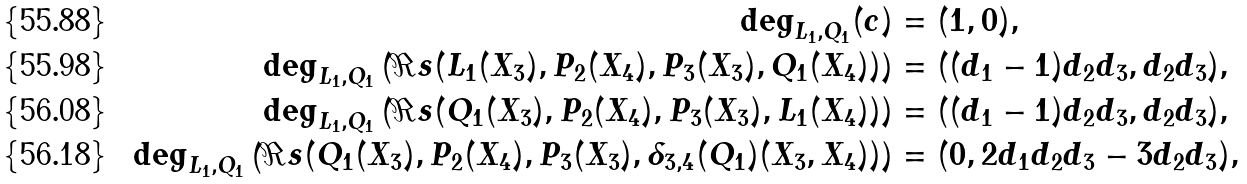<formula> <loc_0><loc_0><loc_500><loc_500>\deg _ { L _ { 1 } , Q _ { 1 } } ( c ) & = ( 1 , 0 ) , \\ \deg _ { L _ { 1 } , Q _ { 1 } } \left ( \Re s ( L _ { 1 } ( X _ { 3 } ) , P _ { 2 } ( X _ { 4 } ) , P _ { 3 } ( X _ { 3 } ) , Q _ { 1 } ( X _ { 4 } ) ) \right ) & = ( ( d _ { 1 } - 1 ) d _ { 2 } d _ { 3 } , d _ { 2 } d _ { 3 } ) , \\ \deg _ { L _ { 1 } , Q _ { 1 } } \left ( \Re s ( Q _ { 1 } ( X _ { 3 } ) , P _ { 2 } ( X _ { 4 } ) , P _ { 3 } ( X _ { 3 } ) , L _ { 1 } ( X _ { 4 } ) ) \right ) & = ( ( d _ { 1 } - 1 ) d _ { 2 } d _ { 3 } , d _ { 2 } d _ { 3 } ) , \\ \deg _ { L _ { 1 } , Q _ { 1 } } \left ( \Re s ( Q _ { 1 } ( X _ { 3 } ) , P _ { 2 } ( X _ { 4 } ) , P _ { 3 } ( X _ { 3 } ) , \delta _ { 3 , 4 } ( Q _ { 1 } ) ( X _ { 3 } , X _ { 4 } ) ) \right ) & = ( 0 , 2 d _ { 1 } d _ { 2 } d _ { 3 } - 3 d _ { 2 } d _ { 3 } ) ,</formula> 